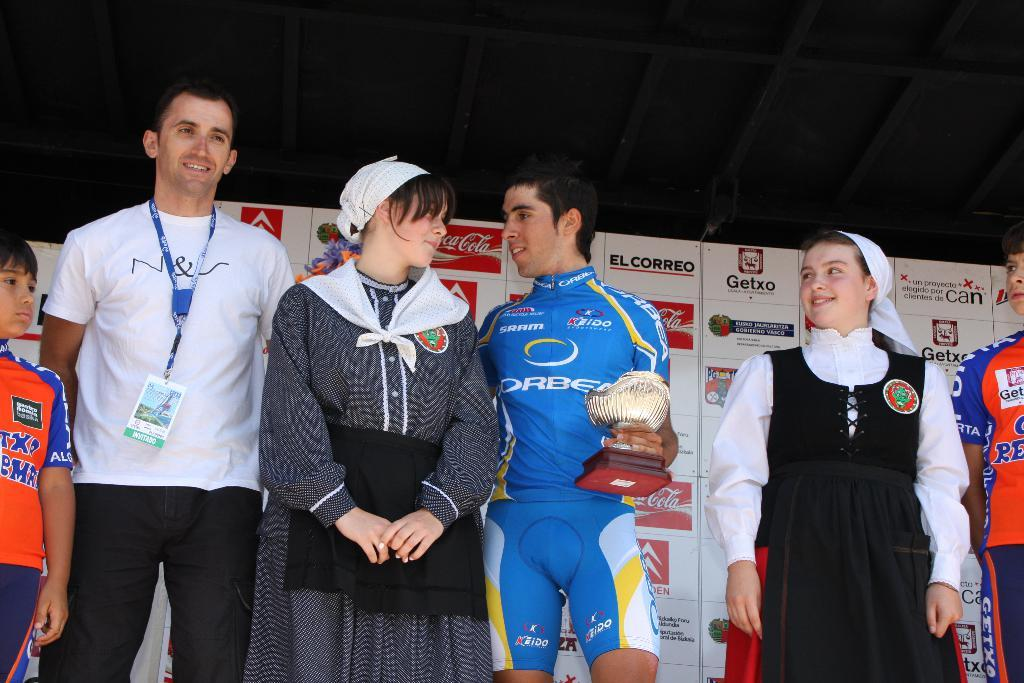Provide a one-sentence caption for the provided image. A winner is presented with a trophy on stage wearing a keido sportswear sponsored jersey. 